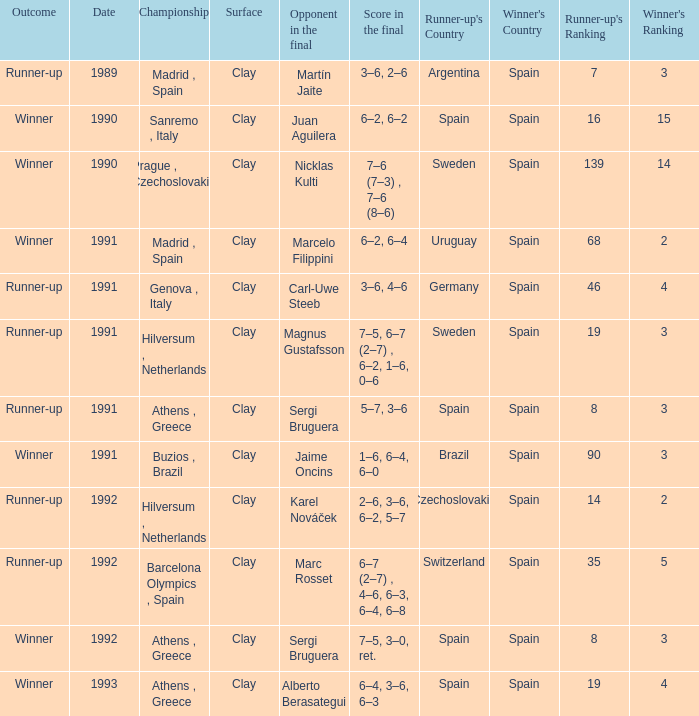What is Opponent In The Final, when Date is before 1991, and when Outcome is "Runner-Up"? Martín Jaite. 